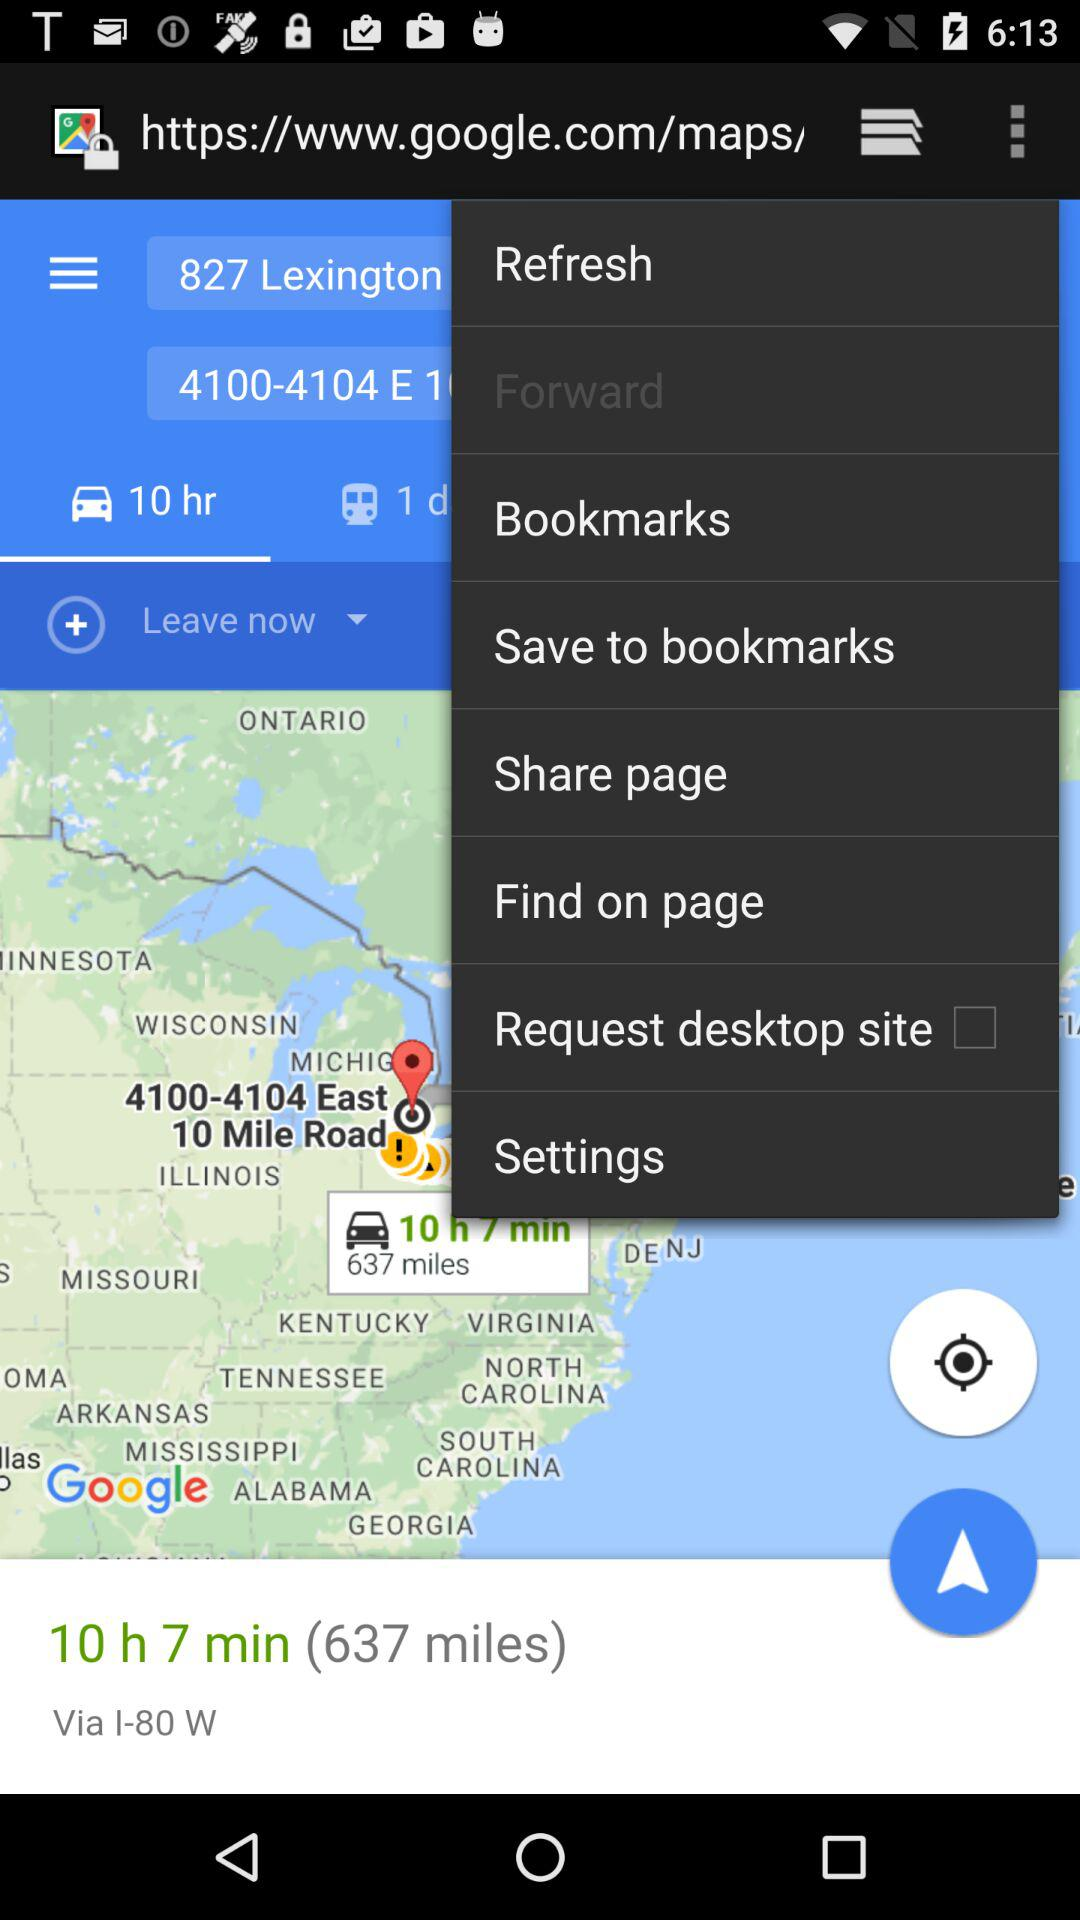How much time will it take to go via the I-80 W highway? It will take 10 hours 7 minutes to go via the I-80 W highway. 